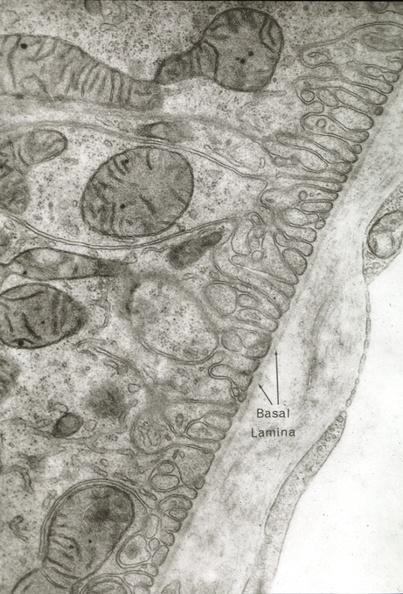what does this image show?
Answer the question using a single word or phrase. Proximal tubule and fenestrated capillary can be used to illustrate capillary epithelial cell relations and functions 